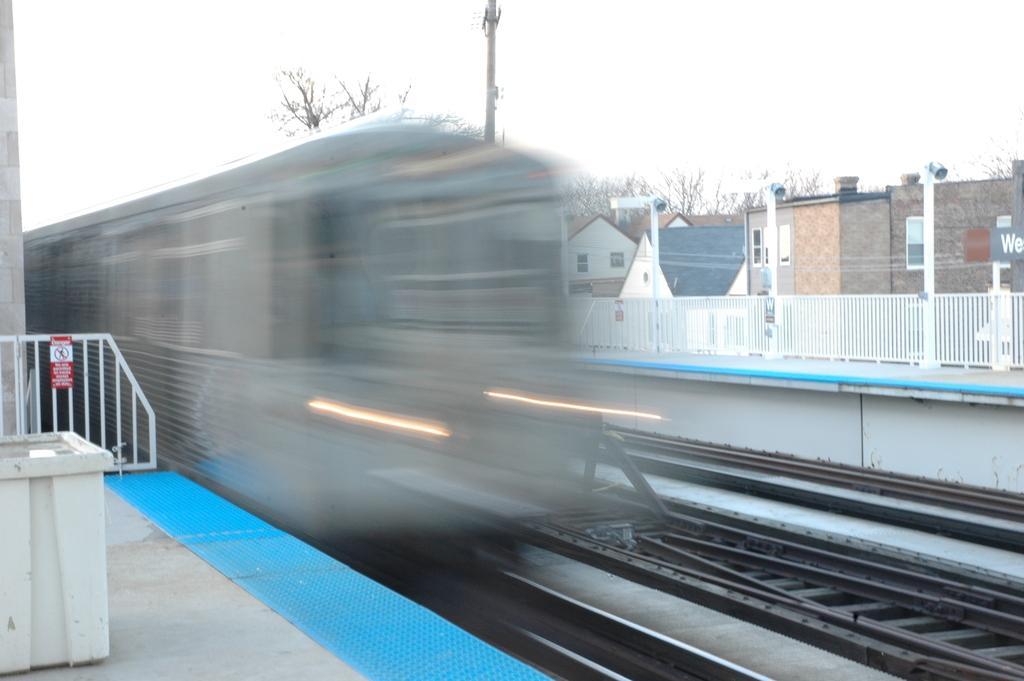Could you give a brief overview of what you see in this image? In the image i can see a railway track and the background is blue. 